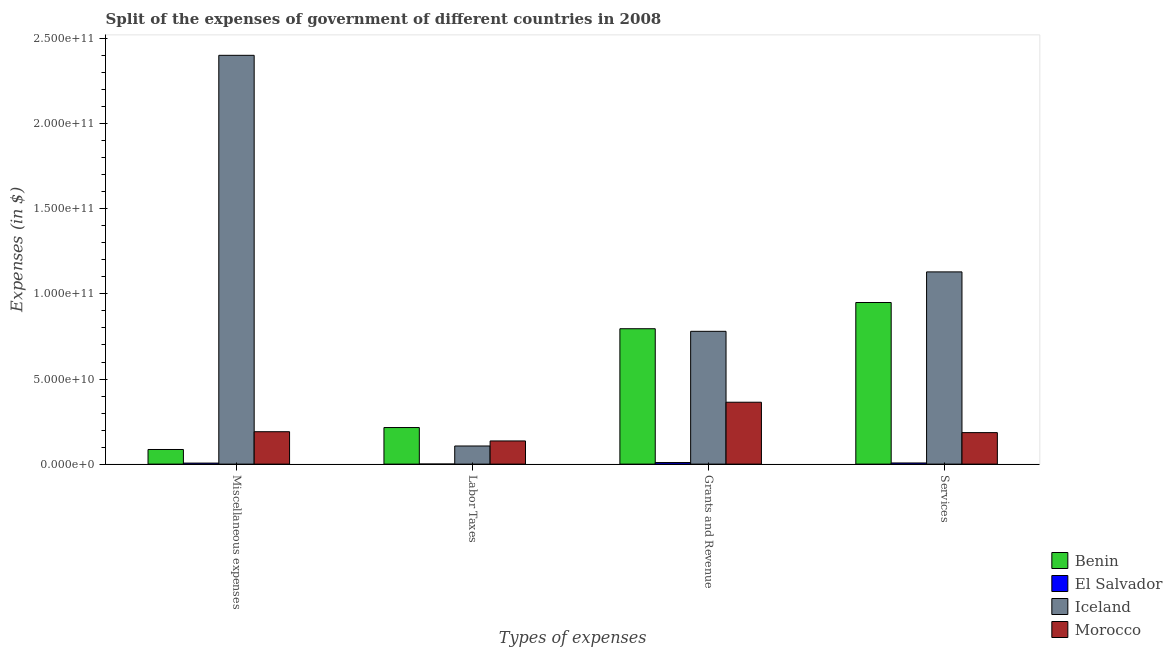How many different coloured bars are there?
Offer a terse response. 4. Are the number of bars per tick equal to the number of legend labels?
Your response must be concise. Yes. How many bars are there on the 1st tick from the left?
Give a very brief answer. 4. How many bars are there on the 4th tick from the right?
Ensure brevity in your answer.  4. What is the label of the 4th group of bars from the left?
Offer a terse response. Services. What is the amount spent on services in Iceland?
Ensure brevity in your answer.  1.13e+11. Across all countries, what is the maximum amount spent on labor taxes?
Keep it short and to the point. 2.15e+1. Across all countries, what is the minimum amount spent on services?
Your answer should be very brief. 6.76e+08. In which country was the amount spent on labor taxes maximum?
Your answer should be very brief. Benin. In which country was the amount spent on grants and revenue minimum?
Give a very brief answer. El Salvador. What is the total amount spent on services in the graph?
Your answer should be compact. 2.27e+11. What is the difference between the amount spent on services in Iceland and that in Morocco?
Make the answer very short. 9.44e+1. What is the difference between the amount spent on miscellaneous expenses in El Salvador and the amount spent on grants and revenue in Morocco?
Your answer should be very brief. -3.58e+1. What is the average amount spent on services per country?
Ensure brevity in your answer.  5.68e+1. What is the difference between the amount spent on services and amount spent on miscellaneous expenses in Benin?
Provide a succinct answer. 8.64e+1. What is the ratio of the amount spent on labor taxes in Morocco to that in El Salvador?
Offer a terse response. 361.03. What is the difference between the highest and the second highest amount spent on labor taxes?
Your answer should be very brief. 7.88e+09. What is the difference between the highest and the lowest amount spent on grants and revenue?
Ensure brevity in your answer.  7.86e+1. In how many countries, is the amount spent on miscellaneous expenses greater than the average amount spent on miscellaneous expenses taken over all countries?
Give a very brief answer. 1. Is the sum of the amount spent on services in El Salvador and Morocco greater than the maximum amount spent on grants and revenue across all countries?
Provide a succinct answer. No. What does the 4th bar from the left in Miscellaneous expenses represents?
Make the answer very short. Morocco. What does the 4th bar from the right in Grants and Revenue represents?
Your answer should be compact. Benin. How many bars are there?
Your response must be concise. 16. Does the graph contain any zero values?
Your answer should be very brief. No. Does the graph contain grids?
Your answer should be compact. No. What is the title of the graph?
Offer a terse response. Split of the expenses of government of different countries in 2008. Does "Curacao" appear as one of the legend labels in the graph?
Your answer should be compact. No. What is the label or title of the X-axis?
Keep it short and to the point. Types of expenses. What is the label or title of the Y-axis?
Make the answer very short. Expenses (in $). What is the Expenses (in $) of Benin in Miscellaneous expenses?
Provide a succinct answer. 8.59e+09. What is the Expenses (in $) of El Salvador in Miscellaneous expenses?
Your response must be concise. 6.06e+08. What is the Expenses (in $) of Iceland in Miscellaneous expenses?
Your response must be concise. 2.40e+11. What is the Expenses (in $) of Morocco in Miscellaneous expenses?
Your answer should be compact. 1.90e+1. What is the Expenses (in $) of Benin in Labor Taxes?
Offer a terse response. 2.15e+1. What is the Expenses (in $) of El Salvador in Labor Taxes?
Ensure brevity in your answer.  3.77e+07. What is the Expenses (in $) in Iceland in Labor Taxes?
Make the answer very short. 1.06e+1. What is the Expenses (in $) in Morocco in Labor Taxes?
Make the answer very short. 1.36e+1. What is the Expenses (in $) in Benin in Grants and Revenue?
Offer a terse response. 7.96e+1. What is the Expenses (in $) in El Salvador in Grants and Revenue?
Your answer should be compact. 9.26e+08. What is the Expenses (in $) of Iceland in Grants and Revenue?
Offer a terse response. 7.80e+1. What is the Expenses (in $) of Morocco in Grants and Revenue?
Offer a terse response. 3.64e+1. What is the Expenses (in $) of Benin in Services?
Provide a short and direct response. 9.50e+1. What is the Expenses (in $) in El Salvador in Services?
Offer a terse response. 6.76e+08. What is the Expenses (in $) of Iceland in Services?
Provide a succinct answer. 1.13e+11. What is the Expenses (in $) in Morocco in Services?
Keep it short and to the point. 1.85e+1. Across all Types of expenses, what is the maximum Expenses (in $) of Benin?
Your response must be concise. 9.50e+1. Across all Types of expenses, what is the maximum Expenses (in $) of El Salvador?
Give a very brief answer. 9.26e+08. Across all Types of expenses, what is the maximum Expenses (in $) of Iceland?
Your answer should be compact. 2.40e+11. Across all Types of expenses, what is the maximum Expenses (in $) of Morocco?
Offer a terse response. 3.64e+1. Across all Types of expenses, what is the minimum Expenses (in $) of Benin?
Offer a terse response. 8.59e+09. Across all Types of expenses, what is the minimum Expenses (in $) of El Salvador?
Your answer should be compact. 3.77e+07. Across all Types of expenses, what is the minimum Expenses (in $) in Iceland?
Provide a succinct answer. 1.06e+1. Across all Types of expenses, what is the minimum Expenses (in $) of Morocco?
Provide a short and direct response. 1.36e+1. What is the total Expenses (in $) of Benin in the graph?
Provide a succinct answer. 2.05e+11. What is the total Expenses (in $) in El Salvador in the graph?
Provide a short and direct response. 2.25e+09. What is the total Expenses (in $) in Iceland in the graph?
Offer a terse response. 4.42e+11. What is the total Expenses (in $) of Morocco in the graph?
Your answer should be compact. 8.75e+1. What is the difference between the Expenses (in $) in Benin in Miscellaneous expenses and that in Labor Taxes?
Offer a terse response. -1.29e+1. What is the difference between the Expenses (in $) of El Salvador in Miscellaneous expenses and that in Labor Taxes?
Provide a short and direct response. 5.69e+08. What is the difference between the Expenses (in $) in Iceland in Miscellaneous expenses and that in Labor Taxes?
Make the answer very short. 2.30e+11. What is the difference between the Expenses (in $) in Morocco in Miscellaneous expenses and that in Labor Taxes?
Your answer should be compact. 5.43e+09. What is the difference between the Expenses (in $) of Benin in Miscellaneous expenses and that in Grants and Revenue?
Give a very brief answer. -7.10e+1. What is the difference between the Expenses (in $) of El Salvador in Miscellaneous expenses and that in Grants and Revenue?
Offer a terse response. -3.19e+08. What is the difference between the Expenses (in $) of Iceland in Miscellaneous expenses and that in Grants and Revenue?
Your response must be concise. 1.62e+11. What is the difference between the Expenses (in $) in Morocco in Miscellaneous expenses and that in Grants and Revenue?
Provide a short and direct response. -1.73e+1. What is the difference between the Expenses (in $) of Benin in Miscellaneous expenses and that in Services?
Keep it short and to the point. -8.64e+1. What is the difference between the Expenses (in $) of El Salvador in Miscellaneous expenses and that in Services?
Your response must be concise. -6.92e+07. What is the difference between the Expenses (in $) in Iceland in Miscellaneous expenses and that in Services?
Offer a terse response. 1.27e+11. What is the difference between the Expenses (in $) in Morocco in Miscellaneous expenses and that in Services?
Offer a very short reply. 5.29e+08. What is the difference between the Expenses (in $) of Benin in Labor Taxes and that in Grants and Revenue?
Your response must be concise. -5.81e+1. What is the difference between the Expenses (in $) in El Salvador in Labor Taxes and that in Grants and Revenue?
Your response must be concise. -8.88e+08. What is the difference between the Expenses (in $) of Iceland in Labor Taxes and that in Grants and Revenue?
Provide a succinct answer. -6.74e+1. What is the difference between the Expenses (in $) in Morocco in Labor Taxes and that in Grants and Revenue?
Keep it short and to the point. -2.28e+1. What is the difference between the Expenses (in $) in Benin in Labor Taxes and that in Services?
Your answer should be very brief. -7.35e+1. What is the difference between the Expenses (in $) of El Salvador in Labor Taxes and that in Services?
Your answer should be compact. -6.38e+08. What is the difference between the Expenses (in $) of Iceland in Labor Taxes and that in Services?
Make the answer very short. -1.02e+11. What is the difference between the Expenses (in $) in Morocco in Labor Taxes and that in Services?
Offer a terse response. -4.90e+09. What is the difference between the Expenses (in $) in Benin in Grants and Revenue and that in Services?
Make the answer very short. -1.54e+1. What is the difference between the Expenses (in $) in El Salvador in Grants and Revenue and that in Services?
Provide a short and direct response. 2.50e+08. What is the difference between the Expenses (in $) in Iceland in Grants and Revenue and that in Services?
Offer a terse response. -3.49e+1. What is the difference between the Expenses (in $) of Morocco in Grants and Revenue and that in Services?
Offer a terse response. 1.79e+1. What is the difference between the Expenses (in $) of Benin in Miscellaneous expenses and the Expenses (in $) of El Salvador in Labor Taxes?
Your answer should be very brief. 8.56e+09. What is the difference between the Expenses (in $) of Benin in Miscellaneous expenses and the Expenses (in $) of Iceland in Labor Taxes?
Ensure brevity in your answer.  -2.06e+09. What is the difference between the Expenses (in $) in Benin in Miscellaneous expenses and the Expenses (in $) in Morocco in Labor Taxes?
Your answer should be compact. -5.02e+09. What is the difference between the Expenses (in $) of El Salvador in Miscellaneous expenses and the Expenses (in $) of Iceland in Labor Taxes?
Provide a short and direct response. -1.00e+1. What is the difference between the Expenses (in $) in El Salvador in Miscellaneous expenses and the Expenses (in $) in Morocco in Labor Taxes?
Provide a succinct answer. -1.30e+1. What is the difference between the Expenses (in $) of Iceland in Miscellaneous expenses and the Expenses (in $) of Morocco in Labor Taxes?
Make the answer very short. 2.27e+11. What is the difference between the Expenses (in $) in Benin in Miscellaneous expenses and the Expenses (in $) in El Salvador in Grants and Revenue?
Offer a very short reply. 7.67e+09. What is the difference between the Expenses (in $) of Benin in Miscellaneous expenses and the Expenses (in $) of Iceland in Grants and Revenue?
Make the answer very short. -6.94e+1. What is the difference between the Expenses (in $) of Benin in Miscellaneous expenses and the Expenses (in $) of Morocco in Grants and Revenue?
Give a very brief answer. -2.78e+1. What is the difference between the Expenses (in $) of El Salvador in Miscellaneous expenses and the Expenses (in $) of Iceland in Grants and Revenue?
Offer a terse response. -7.74e+1. What is the difference between the Expenses (in $) of El Salvador in Miscellaneous expenses and the Expenses (in $) of Morocco in Grants and Revenue?
Give a very brief answer. -3.58e+1. What is the difference between the Expenses (in $) in Iceland in Miscellaneous expenses and the Expenses (in $) in Morocco in Grants and Revenue?
Your answer should be compact. 2.04e+11. What is the difference between the Expenses (in $) in Benin in Miscellaneous expenses and the Expenses (in $) in El Salvador in Services?
Offer a very short reply. 7.92e+09. What is the difference between the Expenses (in $) in Benin in Miscellaneous expenses and the Expenses (in $) in Iceland in Services?
Give a very brief answer. -1.04e+11. What is the difference between the Expenses (in $) in Benin in Miscellaneous expenses and the Expenses (in $) in Morocco in Services?
Provide a succinct answer. -9.91e+09. What is the difference between the Expenses (in $) in El Salvador in Miscellaneous expenses and the Expenses (in $) in Iceland in Services?
Give a very brief answer. -1.12e+11. What is the difference between the Expenses (in $) in El Salvador in Miscellaneous expenses and the Expenses (in $) in Morocco in Services?
Offer a terse response. -1.79e+1. What is the difference between the Expenses (in $) in Iceland in Miscellaneous expenses and the Expenses (in $) in Morocco in Services?
Ensure brevity in your answer.  2.22e+11. What is the difference between the Expenses (in $) in Benin in Labor Taxes and the Expenses (in $) in El Salvador in Grants and Revenue?
Make the answer very short. 2.06e+1. What is the difference between the Expenses (in $) of Benin in Labor Taxes and the Expenses (in $) of Iceland in Grants and Revenue?
Make the answer very short. -5.65e+1. What is the difference between the Expenses (in $) of Benin in Labor Taxes and the Expenses (in $) of Morocco in Grants and Revenue?
Your answer should be compact. -1.49e+1. What is the difference between the Expenses (in $) of El Salvador in Labor Taxes and the Expenses (in $) of Iceland in Grants and Revenue?
Provide a succinct answer. -7.80e+1. What is the difference between the Expenses (in $) of El Salvador in Labor Taxes and the Expenses (in $) of Morocco in Grants and Revenue?
Your answer should be compact. -3.63e+1. What is the difference between the Expenses (in $) in Iceland in Labor Taxes and the Expenses (in $) in Morocco in Grants and Revenue?
Keep it short and to the point. -2.57e+1. What is the difference between the Expenses (in $) of Benin in Labor Taxes and the Expenses (in $) of El Salvador in Services?
Your answer should be very brief. 2.08e+1. What is the difference between the Expenses (in $) in Benin in Labor Taxes and the Expenses (in $) in Iceland in Services?
Make the answer very short. -9.15e+1. What is the difference between the Expenses (in $) of Benin in Labor Taxes and the Expenses (in $) of Morocco in Services?
Ensure brevity in your answer.  2.98e+09. What is the difference between the Expenses (in $) in El Salvador in Labor Taxes and the Expenses (in $) in Iceland in Services?
Offer a terse response. -1.13e+11. What is the difference between the Expenses (in $) of El Salvador in Labor Taxes and the Expenses (in $) of Morocco in Services?
Ensure brevity in your answer.  -1.85e+1. What is the difference between the Expenses (in $) in Iceland in Labor Taxes and the Expenses (in $) in Morocco in Services?
Give a very brief answer. -7.86e+09. What is the difference between the Expenses (in $) in Benin in Grants and Revenue and the Expenses (in $) in El Salvador in Services?
Ensure brevity in your answer.  7.89e+1. What is the difference between the Expenses (in $) in Benin in Grants and Revenue and the Expenses (in $) in Iceland in Services?
Offer a very short reply. -3.34e+1. What is the difference between the Expenses (in $) in Benin in Grants and Revenue and the Expenses (in $) in Morocco in Services?
Your answer should be compact. 6.10e+1. What is the difference between the Expenses (in $) in El Salvador in Grants and Revenue and the Expenses (in $) in Iceland in Services?
Ensure brevity in your answer.  -1.12e+11. What is the difference between the Expenses (in $) of El Salvador in Grants and Revenue and the Expenses (in $) of Morocco in Services?
Keep it short and to the point. -1.76e+1. What is the difference between the Expenses (in $) of Iceland in Grants and Revenue and the Expenses (in $) of Morocco in Services?
Ensure brevity in your answer.  5.95e+1. What is the average Expenses (in $) of Benin per Types of expenses?
Ensure brevity in your answer.  5.11e+1. What is the average Expenses (in $) of El Salvador per Types of expenses?
Your answer should be compact. 5.61e+08. What is the average Expenses (in $) of Iceland per Types of expenses?
Ensure brevity in your answer.  1.10e+11. What is the average Expenses (in $) in Morocco per Types of expenses?
Offer a very short reply. 2.19e+1. What is the difference between the Expenses (in $) in Benin and Expenses (in $) in El Salvador in Miscellaneous expenses?
Provide a succinct answer. 7.99e+09. What is the difference between the Expenses (in $) in Benin and Expenses (in $) in Iceland in Miscellaneous expenses?
Keep it short and to the point. -2.32e+11. What is the difference between the Expenses (in $) in Benin and Expenses (in $) in Morocco in Miscellaneous expenses?
Give a very brief answer. -1.04e+1. What is the difference between the Expenses (in $) of El Salvador and Expenses (in $) of Iceland in Miscellaneous expenses?
Provide a succinct answer. -2.40e+11. What is the difference between the Expenses (in $) in El Salvador and Expenses (in $) in Morocco in Miscellaneous expenses?
Ensure brevity in your answer.  -1.84e+1. What is the difference between the Expenses (in $) of Iceland and Expenses (in $) of Morocco in Miscellaneous expenses?
Provide a short and direct response. 2.21e+11. What is the difference between the Expenses (in $) in Benin and Expenses (in $) in El Salvador in Labor Taxes?
Provide a succinct answer. 2.15e+1. What is the difference between the Expenses (in $) in Benin and Expenses (in $) in Iceland in Labor Taxes?
Make the answer very short. 1.08e+1. What is the difference between the Expenses (in $) in Benin and Expenses (in $) in Morocco in Labor Taxes?
Ensure brevity in your answer.  7.88e+09. What is the difference between the Expenses (in $) in El Salvador and Expenses (in $) in Iceland in Labor Taxes?
Provide a short and direct response. -1.06e+1. What is the difference between the Expenses (in $) in El Salvador and Expenses (in $) in Morocco in Labor Taxes?
Keep it short and to the point. -1.36e+1. What is the difference between the Expenses (in $) of Iceland and Expenses (in $) of Morocco in Labor Taxes?
Your response must be concise. -2.96e+09. What is the difference between the Expenses (in $) in Benin and Expenses (in $) in El Salvador in Grants and Revenue?
Offer a terse response. 7.86e+1. What is the difference between the Expenses (in $) of Benin and Expenses (in $) of Iceland in Grants and Revenue?
Your answer should be very brief. 1.52e+09. What is the difference between the Expenses (in $) in Benin and Expenses (in $) in Morocco in Grants and Revenue?
Make the answer very short. 4.32e+1. What is the difference between the Expenses (in $) in El Salvador and Expenses (in $) in Iceland in Grants and Revenue?
Offer a terse response. -7.71e+1. What is the difference between the Expenses (in $) of El Salvador and Expenses (in $) of Morocco in Grants and Revenue?
Provide a succinct answer. -3.54e+1. What is the difference between the Expenses (in $) in Iceland and Expenses (in $) in Morocco in Grants and Revenue?
Provide a short and direct response. 4.17e+1. What is the difference between the Expenses (in $) of Benin and Expenses (in $) of El Salvador in Services?
Provide a succinct answer. 9.43e+1. What is the difference between the Expenses (in $) in Benin and Expenses (in $) in Iceland in Services?
Keep it short and to the point. -1.80e+1. What is the difference between the Expenses (in $) of Benin and Expenses (in $) of Morocco in Services?
Give a very brief answer. 7.65e+1. What is the difference between the Expenses (in $) in El Salvador and Expenses (in $) in Iceland in Services?
Your answer should be compact. -1.12e+11. What is the difference between the Expenses (in $) of El Salvador and Expenses (in $) of Morocco in Services?
Give a very brief answer. -1.78e+1. What is the difference between the Expenses (in $) of Iceland and Expenses (in $) of Morocco in Services?
Provide a short and direct response. 9.44e+1. What is the ratio of the Expenses (in $) of Benin in Miscellaneous expenses to that in Labor Taxes?
Your answer should be very brief. 0.4. What is the ratio of the Expenses (in $) in El Salvador in Miscellaneous expenses to that in Labor Taxes?
Provide a succinct answer. 16.08. What is the ratio of the Expenses (in $) of Iceland in Miscellaneous expenses to that in Labor Taxes?
Give a very brief answer. 22.56. What is the ratio of the Expenses (in $) of Morocco in Miscellaneous expenses to that in Labor Taxes?
Provide a short and direct response. 1.4. What is the ratio of the Expenses (in $) of Benin in Miscellaneous expenses to that in Grants and Revenue?
Your response must be concise. 0.11. What is the ratio of the Expenses (in $) in El Salvador in Miscellaneous expenses to that in Grants and Revenue?
Provide a short and direct response. 0.66. What is the ratio of the Expenses (in $) of Iceland in Miscellaneous expenses to that in Grants and Revenue?
Your response must be concise. 3.08. What is the ratio of the Expenses (in $) of Morocco in Miscellaneous expenses to that in Grants and Revenue?
Keep it short and to the point. 0.52. What is the ratio of the Expenses (in $) of Benin in Miscellaneous expenses to that in Services?
Your response must be concise. 0.09. What is the ratio of the Expenses (in $) in El Salvador in Miscellaneous expenses to that in Services?
Ensure brevity in your answer.  0.9. What is the ratio of the Expenses (in $) in Iceland in Miscellaneous expenses to that in Services?
Your answer should be compact. 2.13. What is the ratio of the Expenses (in $) of Morocco in Miscellaneous expenses to that in Services?
Your answer should be very brief. 1.03. What is the ratio of the Expenses (in $) of Benin in Labor Taxes to that in Grants and Revenue?
Your response must be concise. 0.27. What is the ratio of the Expenses (in $) of El Salvador in Labor Taxes to that in Grants and Revenue?
Keep it short and to the point. 0.04. What is the ratio of the Expenses (in $) in Iceland in Labor Taxes to that in Grants and Revenue?
Provide a succinct answer. 0.14. What is the ratio of the Expenses (in $) of Morocco in Labor Taxes to that in Grants and Revenue?
Keep it short and to the point. 0.37. What is the ratio of the Expenses (in $) of Benin in Labor Taxes to that in Services?
Your response must be concise. 0.23. What is the ratio of the Expenses (in $) of El Salvador in Labor Taxes to that in Services?
Provide a short and direct response. 0.06. What is the ratio of the Expenses (in $) of Iceland in Labor Taxes to that in Services?
Make the answer very short. 0.09. What is the ratio of the Expenses (in $) in Morocco in Labor Taxes to that in Services?
Make the answer very short. 0.74. What is the ratio of the Expenses (in $) in Benin in Grants and Revenue to that in Services?
Your answer should be very brief. 0.84. What is the ratio of the Expenses (in $) of El Salvador in Grants and Revenue to that in Services?
Your response must be concise. 1.37. What is the ratio of the Expenses (in $) in Iceland in Grants and Revenue to that in Services?
Your response must be concise. 0.69. What is the ratio of the Expenses (in $) of Morocco in Grants and Revenue to that in Services?
Keep it short and to the point. 1.96. What is the difference between the highest and the second highest Expenses (in $) of Benin?
Make the answer very short. 1.54e+1. What is the difference between the highest and the second highest Expenses (in $) in El Salvador?
Make the answer very short. 2.50e+08. What is the difference between the highest and the second highest Expenses (in $) of Iceland?
Your answer should be compact. 1.27e+11. What is the difference between the highest and the second highest Expenses (in $) of Morocco?
Offer a terse response. 1.73e+1. What is the difference between the highest and the lowest Expenses (in $) in Benin?
Your answer should be very brief. 8.64e+1. What is the difference between the highest and the lowest Expenses (in $) in El Salvador?
Your answer should be very brief. 8.88e+08. What is the difference between the highest and the lowest Expenses (in $) of Iceland?
Make the answer very short. 2.30e+11. What is the difference between the highest and the lowest Expenses (in $) in Morocco?
Your answer should be compact. 2.28e+1. 